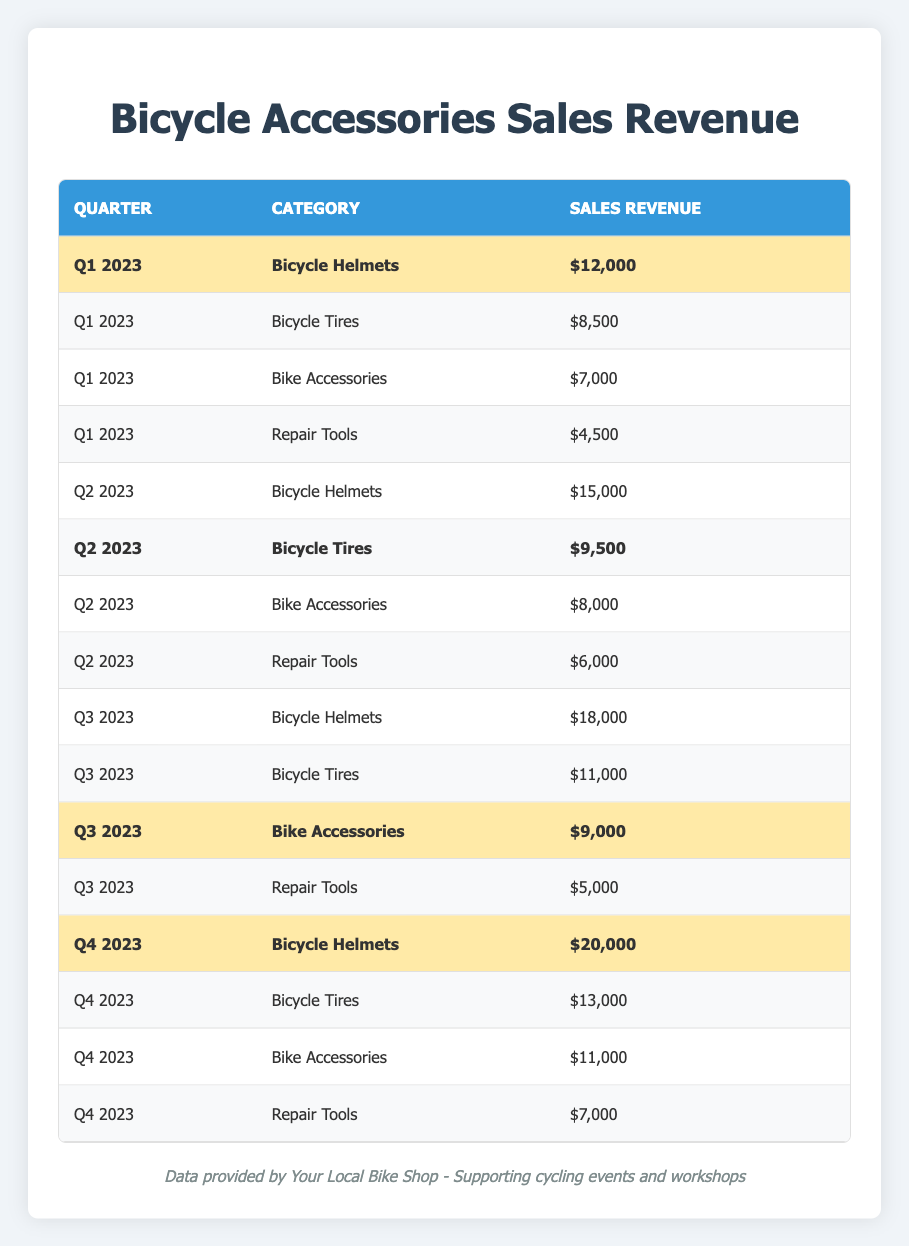What was the highest sales revenue for bicycle helmets in 2023? The highest sales revenue for bicycle helmets occurred in Q4 2023 with a revenue of $20,000.
Answer: $20,000 In which quarter did bicycle tires generate $9,500 in sales revenue? Bicycle tires generated $9,500 in sales revenue in Q2 2023, as indicated in the table.
Answer: Q2 2023 Which category had the least sales revenue in Q1 2023? The category with the least sales revenue in Q1 2023 was Repair Tools, with a sales revenue of $4,500.
Answer: Repair Tools What is the total sales revenue from bike accessories across all four quarters? Adding the sales revenue from bike accessories: $7,000 (Q1) + $8,000 (Q2) + $9,000 (Q3) + $11,000 (Q4) gives a total of $35,000.
Answer: $35,000 Did the sales revenue for bicycle helmets increase every quarter in 2023? Yes, the sales revenue for bicycle helmets increased in each quarter: $12,000 (Q1), $15,000 (Q2), $18,000 (Q3), and $20,000 (Q4).
Answer: Yes What was the difference in sales revenue for bicycle tires between Q2 2023 and Q3 2023? The sales revenue for bicycle tires in Q2 2023 was $9,500, and in Q3 2023, it was $11,000. The difference is $11,000 - $9,500 = $1,500.
Answer: $1,500 Which category had the maximum sales revenue in Q3 2023? In Q3 2023, the maximum sales revenue was from Bicycle Helmets, totaling $18,000, although Bike Accessories were also significant at $9,000.
Answer: Bicycle Helmets What are the average sales revenues for bicycle accessories over the four quarters? The sales revenues for bike accessories are $7,000 (Q1), $8,000 (Q2), $9,000 (Q3), and $11,000 (Q4). The total is $35,000, and dividing by 4 gives an average of $8,750.
Answer: $8,750 Did any quarter have highlighted values without recorded revenue for repair tools? Yes, Q3 and Q4 both had no highlighted revenue for repair tools, while highlighted categories include Bicycle Helmets in Q4.
Answer: Yes What was the percentage increase in sales revenue for bicycle helmets from Q1 to Q4 2023? Sales revenue for bicycle helmets increased from $12,000 in Q1 to $20,000 in Q4, a difference of $8,000. The percentage increase is ($8,000 / $12,000) * 100 = 66.67%.
Answer: 66.67% 